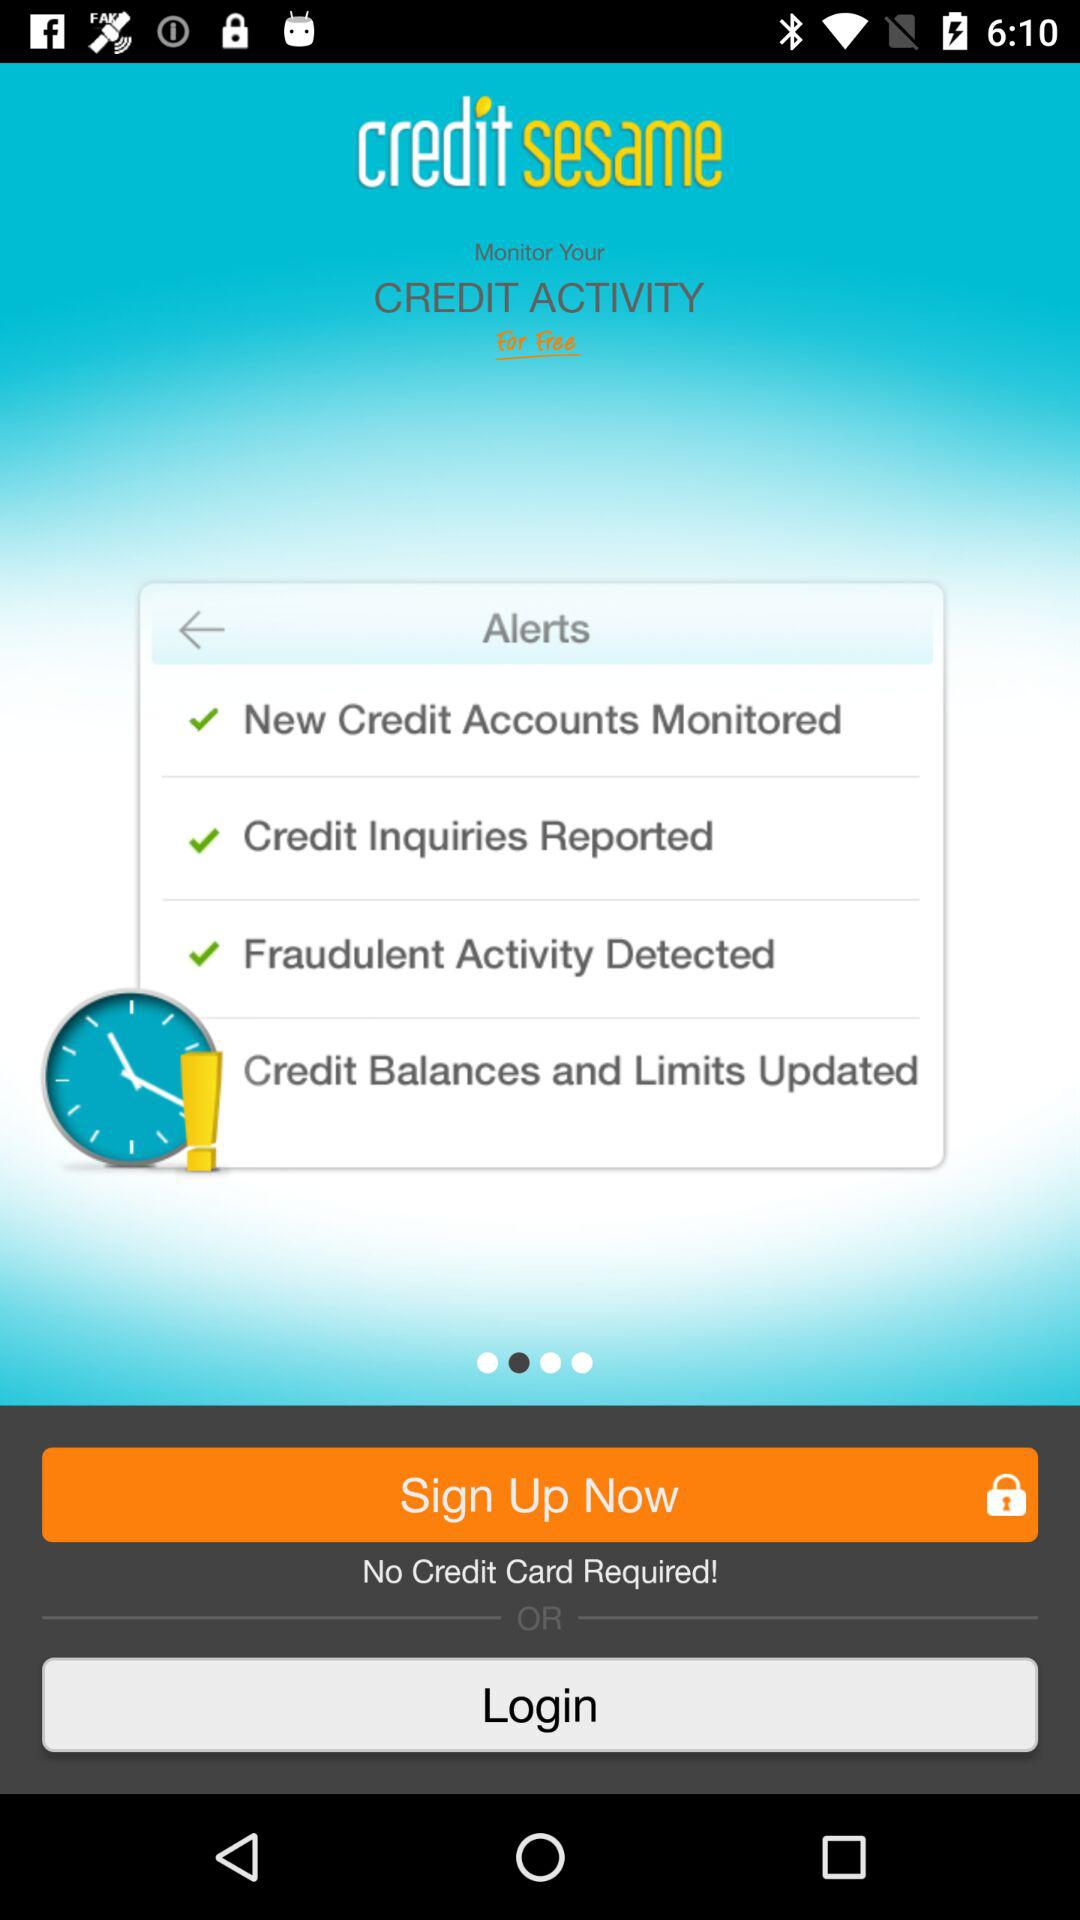How many types of alerts are displayed?
Answer the question using a single word or phrase. 4 